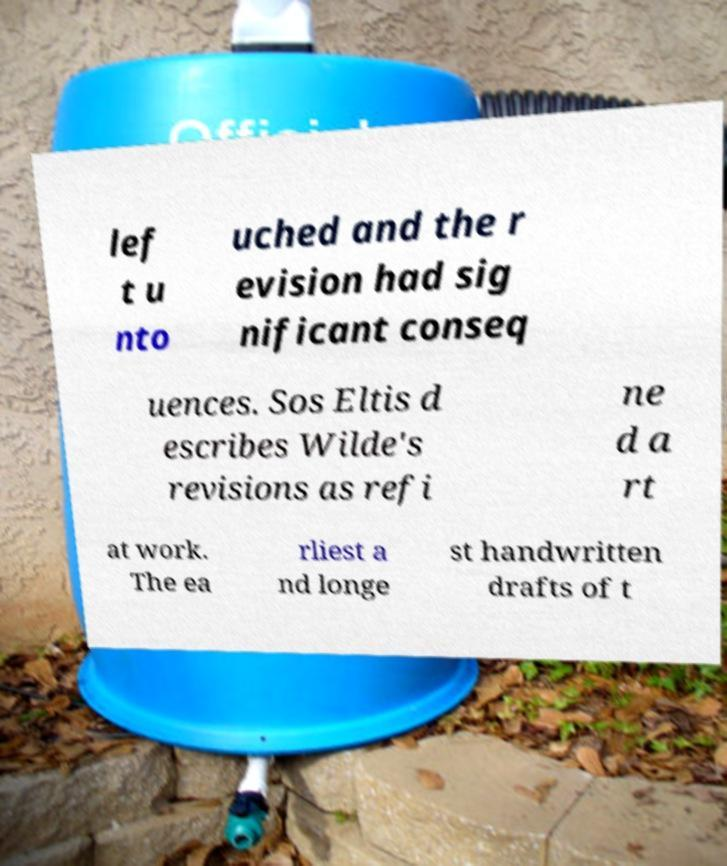Can you read and provide the text displayed in the image?This photo seems to have some interesting text. Can you extract and type it out for me? lef t u nto uched and the r evision had sig nificant conseq uences. Sos Eltis d escribes Wilde's revisions as refi ne d a rt at work. The ea rliest a nd longe st handwritten drafts of t 